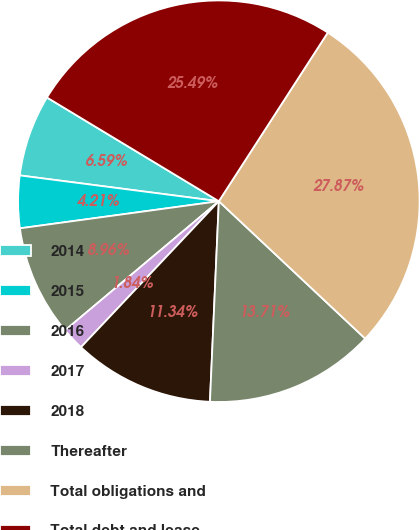<chart> <loc_0><loc_0><loc_500><loc_500><pie_chart><fcel>2014<fcel>2015<fcel>2016<fcel>2017<fcel>2018<fcel>Thereafter<fcel>Total obligations and<fcel>Total debt and lease<nl><fcel>6.59%<fcel>4.21%<fcel>8.96%<fcel>1.84%<fcel>11.34%<fcel>13.71%<fcel>27.87%<fcel>25.49%<nl></chart> 